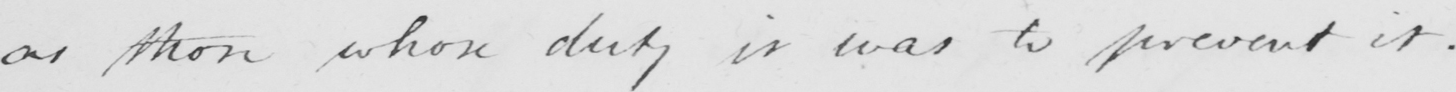What is written in this line of handwriting? as those whose duty it was to prevent it . 